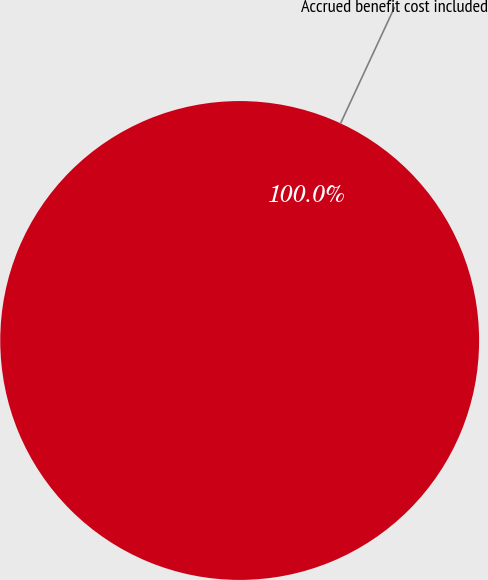Convert chart to OTSL. <chart><loc_0><loc_0><loc_500><loc_500><pie_chart><fcel>Accrued benefit cost included<nl><fcel>100.0%<nl></chart> 